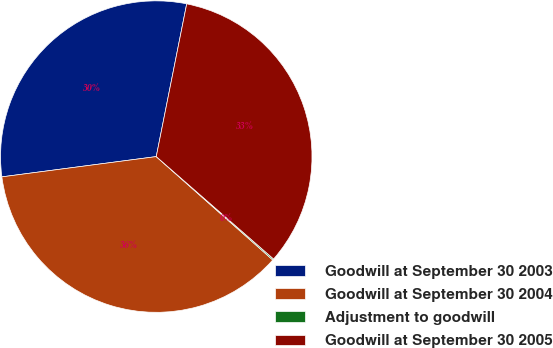Convert chart. <chart><loc_0><loc_0><loc_500><loc_500><pie_chart><fcel>Goodwill at September 30 2003<fcel>Goodwill at September 30 2004<fcel>Adjustment to goodwill<fcel>Goodwill at September 30 2005<nl><fcel>30.21%<fcel>36.37%<fcel>0.13%<fcel>33.29%<nl></chart> 